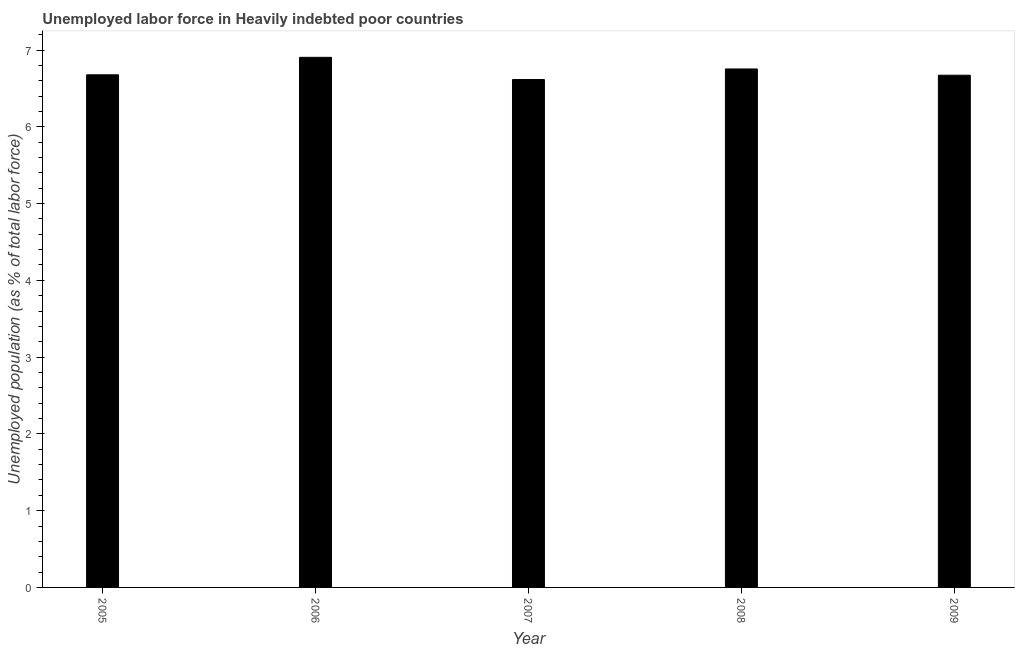What is the title of the graph?
Offer a very short reply. Unemployed labor force in Heavily indebted poor countries. What is the label or title of the X-axis?
Give a very brief answer. Year. What is the label or title of the Y-axis?
Keep it short and to the point. Unemployed population (as % of total labor force). What is the total unemployed population in 2008?
Give a very brief answer. 6.75. Across all years, what is the maximum total unemployed population?
Ensure brevity in your answer.  6.9. Across all years, what is the minimum total unemployed population?
Provide a succinct answer. 6.62. What is the sum of the total unemployed population?
Offer a very short reply. 33.62. What is the difference between the total unemployed population in 2005 and 2008?
Provide a succinct answer. -0.08. What is the average total unemployed population per year?
Provide a short and direct response. 6.72. What is the median total unemployed population?
Offer a terse response. 6.68. In how many years, is the total unemployed population greater than 0.6 %?
Offer a terse response. 5. What is the ratio of the total unemployed population in 2007 to that in 2008?
Your answer should be compact. 0.98. Is the total unemployed population in 2006 less than that in 2008?
Ensure brevity in your answer.  No. What is the difference between the highest and the second highest total unemployed population?
Offer a very short reply. 0.15. What is the difference between the highest and the lowest total unemployed population?
Provide a short and direct response. 0.29. How many bars are there?
Keep it short and to the point. 5. What is the Unemployed population (as % of total labor force) in 2005?
Your answer should be very brief. 6.68. What is the Unemployed population (as % of total labor force) in 2006?
Keep it short and to the point. 6.9. What is the Unemployed population (as % of total labor force) of 2007?
Offer a terse response. 6.62. What is the Unemployed population (as % of total labor force) in 2008?
Your response must be concise. 6.75. What is the Unemployed population (as % of total labor force) in 2009?
Ensure brevity in your answer.  6.67. What is the difference between the Unemployed population (as % of total labor force) in 2005 and 2006?
Offer a very short reply. -0.23. What is the difference between the Unemployed population (as % of total labor force) in 2005 and 2007?
Your answer should be compact. 0.06. What is the difference between the Unemployed population (as % of total labor force) in 2005 and 2008?
Offer a terse response. -0.08. What is the difference between the Unemployed population (as % of total labor force) in 2005 and 2009?
Your answer should be compact. 0.01. What is the difference between the Unemployed population (as % of total labor force) in 2006 and 2007?
Provide a succinct answer. 0.29. What is the difference between the Unemployed population (as % of total labor force) in 2006 and 2008?
Offer a very short reply. 0.15. What is the difference between the Unemployed population (as % of total labor force) in 2006 and 2009?
Provide a succinct answer. 0.23. What is the difference between the Unemployed population (as % of total labor force) in 2007 and 2008?
Your response must be concise. -0.14. What is the difference between the Unemployed population (as % of total labor force) in 2007 and 2009?
Your answer should be very brief. -0.06. What is the difference between the Unemployed population (as % of total labor force) in 2008 and 2009?
Offer a very short reply. 0.08. What is the ratio of the Unemployed population (as % of total labor force) in 2006 to that in 2007?
Give a very brief answer. 1.04. What is the ratio of the Unemployed population (as % of total labor force) in 2006 to that in 2009?
Keep it short and to the point. 1.03. What is the ratio of the Unemployed population (as % of total labor force) in 2007 to that in 2008?
Offer a very short reply. 0.98. What is the ratio of the Unemployed population (as % of total labor force) in 2007 to that in 2009?
Your response must be concise. 0.99. 